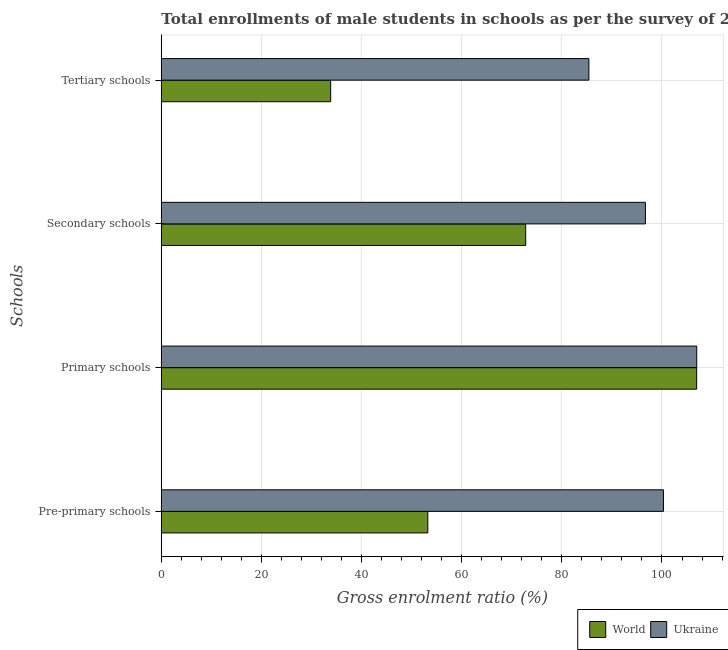How many groups of bars are there?
Offer a terse response. 4. Are the number of bars on each tick of the Y-axis equal?
Offer a very short reply. Yes. How many bars are there on the 2nd tick from the top?
Make the answer very short. 2. What is the label of the 2nd group of bars from the top?
Offer a terse response. Secondary schools. What is the gross enrolment ratio(male) in primary schools in World?
Provide a short and direct response. 106.93. Across all countries, what is the maximum gross enrolment ratio(male) in tertiary schools?
Ensure brevity in your answer.  85.4. Across all countries, what is the minimum gross enrolment ratio(male) in secondary schools?
Provide a succinct answer. 72.77. In which country was the gross enrolment ratio(male) in primary schools maximum?
Your answer should be compact. Ukraine. In which country was the gross enrolment ratio(male) in pre-primary schools minimum?
Your answer should be compact. World. What is the total gross enrolment ratio(male) in primary schools in the graph?
Ensure brevity in your answer.  213.87. What is the difference between the gross enrolment ratio(male) in secondary schools in Ukraine and that in World?
Give a very brief answer. 23.92. What is the difference between the gross enrolment ratio(male) in secondary schools in Ukraine and the gross enrolment ratio(male) in pre-primary schools in World?
Your answer should be very brief. 43.46. What is the average gross enrolment ratio(male) in secondary schools per country?
Offer a very short reply. 84.73. What is the difference between the gross enrolment ratio(male) in secondary schools and gross enrolment ratio(male) in primary schools in Ukraine?
Your response must be concise. -10.25. What is the ratio of the gross enrolment ratio(male) in secondary schools in World to that in Ukraine?
Offer a terse response. 0.75. What is the difference between the highest and the second highest gross enrolment ratio(male) in secondary schools?
Offer a very short reply. 23.92. What is the difference between the highest and the lowest gross enrolment ratio(male) in secondary schools?
Your response must be concise. 23.92. In how many countries, is the gross enrolment ratio(male) in primary schools greater than the average gross enrolment ratio(male) in primary schools taken over all countries?
Offer a very short reply. 1. Is it the case that in every country, the sum of the gross enrolment ratio(male) in primary schools and gross enrolment ratio(male) in tertiary schools is greater than the sum of gross enrolment ratio(male) in secondary schools and gross enrolment ratio(male) in pre-primary schools?
Offer a very short reply. No. What does the 1st bar from the top in Tertiary schools represents?
Offer a terse response. Ukraine. What does the 2nd bar from the bottom in Tertiary schools represents?
Your answer should be compact. Ukraine. Are all the bars in the graph horizontal?
Keep it short and to the point. Yes. How many countries are there in the graph?
Your response must be concise. 2. Does the graph contain grids?
Offer a terse response. Yes. How are the legend labels stacked?
Your answer should be compact. Horizontal. What is the title of the graph?
Your response must be concise. Total enrollments of male students in schools as per the survey of 2012 conducted in different countries. What is the label or title of the X-axis?
Provide a succinct answer. Gross enrolment ratio (%). What is the label or title of the Y-axis?
Your answer should be very brief. Schools. What is the Gross enrolment ratio (%) in World in Pre-primary schools?
Make the answer very short. 53.23. What is the Gross enrolment ratio (%) of Ukraine in Pre-primary schools?
Make the answer very short. 100.29. What is the Gross enrolment ratio (%) of World in Primary schools?
Offer a terse response. 106.93. What is the Gross enrolment ratio (%) in Ukraine in Primary schools?
Your response must be concise. 106.94. What is the Gross enrolment ratio (%) of World in Secondary schools?
Give a very brief answer. 72.77. What is the Gross enrolment ratio (%) of Ukraine in Secondary schools?
Your answer should be very brief. 96.69. What is the Gross enrolment ratio (%) in World in Tertiary schools?
Keep it short and to the point. 33.83. What is the Gross enrolment ratio (%) of Ukraine in Tertiary schools?
Provide a short and direct response. 85.4. Across all Schools, what is the maximum Gross enrolment ratio (%) of World?
Provide a succinct answer. 106.93. Across all Schools, what is the maximum Gross enrolment ratio (%) in Ukraine?
Make the answer very short. 106.94. Across all Schools, what is the minimum Gross enrolment ratio (%) in World?
Your answer should be very brief. 33.83. Across all Schools, what is the minimum Gross enrolment ratio (%) in Ukraine?
Ensure brevity in your answer.  85.4. What is the total Gross enrolment ratio (%) in World in the graph?
Offer a very short reply. 266.76. What is the total Gross enrolment ratio (%) in Ukraine in the graph?
Provide a succinct answer. 389.32. What is the difference between the Gross enrolment ratio (%) of World in Pre-primary schools and that in Primary schools?
Ensure brevity in your answer.  -53.7. What is the difference between the Gross enrolment ratio (%) in Ukraine in Pre-primary schools and that in Primary schools?
Give a very brief answer. -6.64. What is the difference between the Gross enrolment ratio (%) of World in Pre-primary schools and that in Secondary schools?
Provide a succinct answer. -19.55. What is the difference between the Gross enrolment ratio (%) of Ukraine in Pre-primary schools and that in Secondary schools?
Give a very brief answer. 3.6. What is the difference between the Gross enrolment ratio (%) of World in Pre-primary schools and that in Tertiary schools?
Your answer should be very brief. 19.4. What is the difference between the Gross enrolment ratio (%) in Ukraine in Pre-primary schools and that in Tertiary schools?
Keep it short and to the point. 14.89. What is the difference between the Gross enrolment ratio (%) of World in Primary schools and that in Secondary schools?
Your answer should be compact. 34.16. What is the difference between the Gross enrolment ratio (%) in Ukraine in Primary schools and that in Secondary schools?
Your answer should be very brief. 10.25. What is the difference between the Gross enrolment ratio (%) of World in Primary schools and that in Tertiary schools?
Keep it short and to the point. 73.1. What is the difference between the Gross enrolment ratio (%) in Ukraine in Primary schools and that in Tertiary schools?
Offer a very short reply. 21.54. What is the difference between the Gross enrolment ratio (%) in World in Secondary schools and that in Tertiary schools?
Give a very brief answer. 38.95. What is the difference between the Gross enrolment ratio (%) of Ukraine in Secondary schools and that in Tertiary schools?
Provide a succinct answer. 11.29. What is the difference between the Gross enrolment ratio (%) in World in Pre-primary schools and the Gross enrolment ratio (%) in Ukraine in Primary schools?
Your answer should be compact. -53.71. What is the difference between the Gross enrolment ratio (%) of World in Pre-primary schools and the Gross enrolment ratio (%) of Ukraine in Secondary schools?
Offer a terse response. -43.46. What is the difference between the Gross enrolment ratio (%) of World in Pre-primary schools and the Gross enrolment ratio (%) of Ukraine in Tertiary schools?
Give a very brief answer. -32.17. What is the difference between the Gross enrolment ratio (%) of World in Primary schools and the Gross enrolment ratio (%) of Ukraine in Secondary schools?
Give a very brief answer. 10.24. What is the difference between the Gross enrolment ratio (%) of World in Primary schools and the Gross enrolment ratio (%) of Ukraine in Tertiary schools?
Your answer should be compact. 21.53. What is the difference between the Gross enrolment ratio (%) of World in Secondary schools and the Gross enrolment ratio (%) of Ukraine in Tertiary schools?
Ensure brevity in your answer.  -12.63. What is the average Gross enrolment ratio (%) of World per Schools?
Provide a succinct answer. 66.69. What is the average Gross enrolment ratio (%) of Ukraine per Schools?
Provide a succinct answer. 97.33. What is the difference between the Gross enrolment ratio (%) in World and Gross enrolment ratio (%) in Ukraine in Pre-primary schools?
Keep it short and to the point. -47.07. What is the difference between the Gross enrolment ratio (%) in World and Gross enrolment ratio (%) in Ukraine in Primary schools?
Offer a terse response. -0.01. What is the difference between the Gross enrolment ratio (%) of World and Gross enrolment ratio (%) of Ukraine in Secondary schools?
Offer a terse response. -23.92. What is the difference between the Gross enrolment ratio (%) of World and Gross enrolment ratio (%) of Ukraine in Tertiary schools?
Offer a very short reply. -51.57. What is the ratio of the Gross enrolment ratio (%) of World in Pre-primary schools to that in Primary schools?
Give a very brief answer. 0.5. What is the ratio of the Gross enrolment ratio (%) in Ukraine in Pre-primary schools to that in Primary schools?
Ensure brevity in your answer.  0.94. What is the ratio of the Gross enrolment ratio (%) of World in Pre-primary schools to that in Secondary schools?
Offer a very short reply. 0.73. What is the ratio of the Gross enrolment ratio (%) in Ukraine in Pre-primary schools to that in Secondary schools?
Your response must be concise. 1.04. What is the ratio of the Gross enrolment ratio (%) in World in Pre-primary schools to that in Tertiary schools?
Make the answer very short. 1.57. What is the ratio of the Gross enrolment ratio (%) of Ukraine in Pre-primary schools to that in Tertiary schools?
Your response must be concise. 1.17. What is the ratio of the Gross enrolment ratio (%) in World in Primary schools to that in Secondary schools?
Make the answer very short. 1.47. What is the ratio of the Gross enrolment ratio (%) of Ukraine in Primary schools to that in Secondary schools?
Your answer should be very brief. 1.11. What is the ratio of the Gross enrolment ratio (%) in World in Primary schools to that in Tertiary schools?
Your answer should be very brief. 3.16. What is the ratio of the Gross enrolment ratio (%) in Ukraine in Primary schools to that in Tertiary schools?
Your response must be concise. 1.25. What is the ratio of the Gross enrolment ratio (%) of World in Secondary schools to that in Tertiary schools?
Offer a terse response. 2.15. What is the ratio of the Gross enrolment ratio (%) in Ukraine in Secondary schools to that in Tertiary schools?
Provide a succinct answer. 1.13. What is the difference between the highest and the second highest Gross enrolment ratio (%) in World?
Ensure brevity in your answer.  34.16. What is the difference between the highest and the second highest Gross enrolment ratio (%) of Ukraine?
Give a very brief answer. 6.64. What is the difference between the highest and the lowest Gross enrolment ratio (%) in World?
Your answer should be compact. 73.1. What is the difference between the highest and the lowest Gross enrolment ratio (%) in Ukraine?
Offer a very short reply. 21.54. 